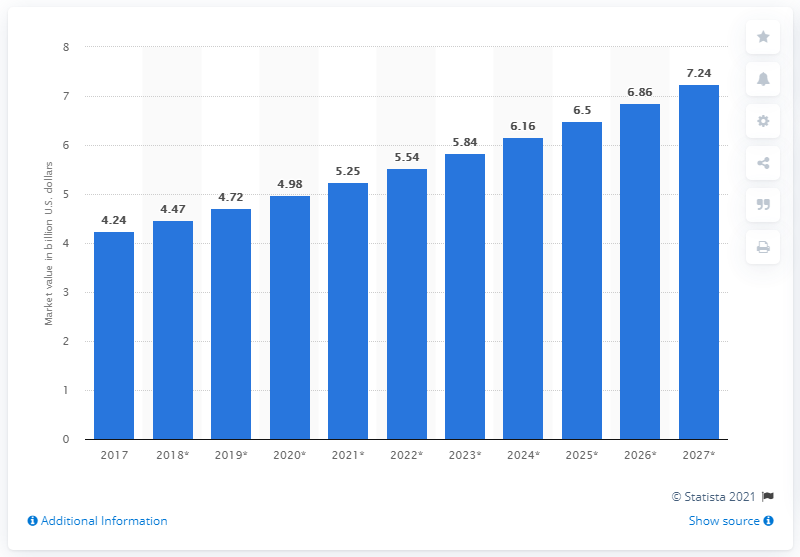Identify some key points in this picture. In 2017, the global aquaculture market was valued at approximately 4.24 billion dollars. The global aquaculture market was valued at approximately 4.2 billion U.S. dollars in the year 2017. The global aquaculture market is forecasted to reach $7.24 billion by 2027. 